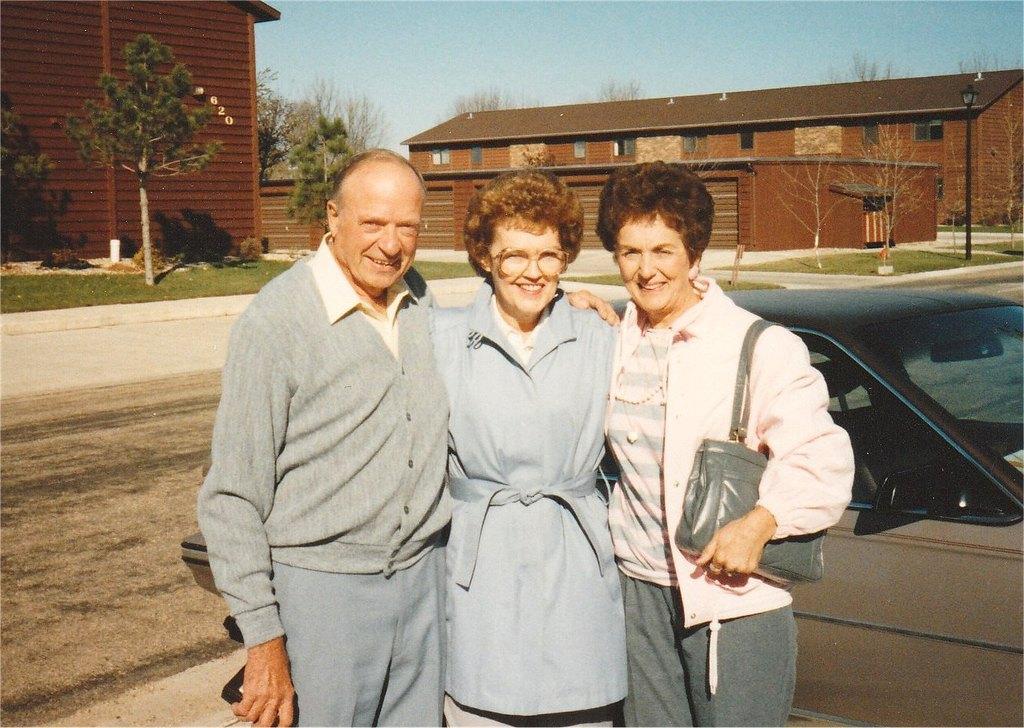How would you summarize this image in a sentence or two? There are three persons in different color dresses, smiling and standing. Beside them, there is a vehicle. In the background, there are buildings having roofs, there are trees and there is blue sky. 